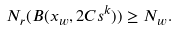<formula> <loc_0><loc_0><loc_500><loc_500>N _ { r } ( B ( x _ { w } , 2 C s ^ { k } ) ) \geq N _ { w } .</formula> 